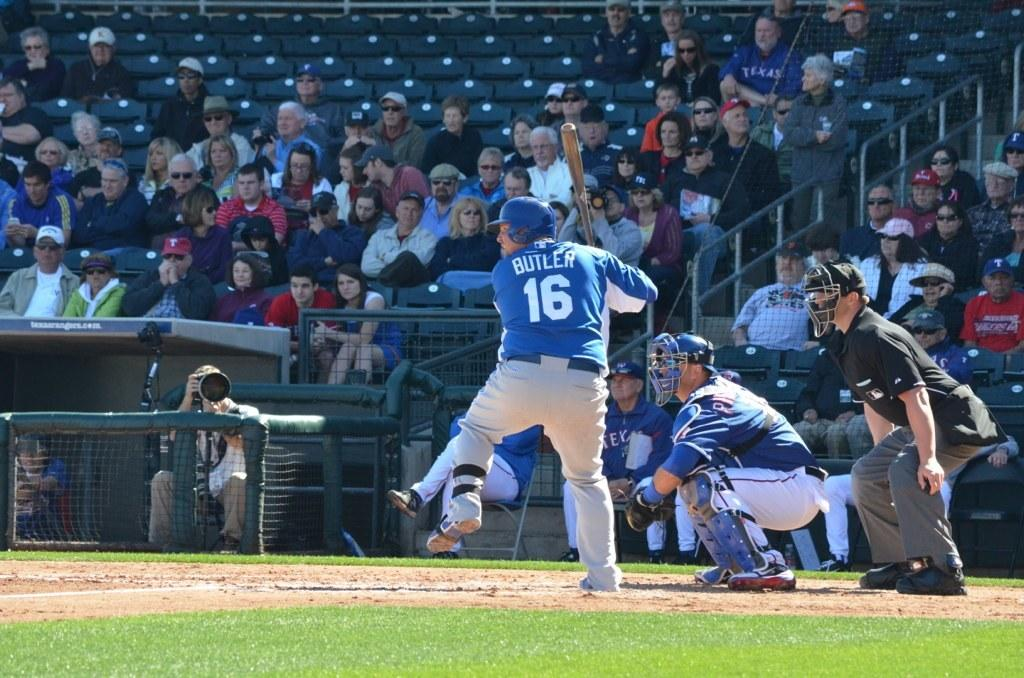Provide a one-sentence caption for the provided image. A baseball player named Butler is about to hit the ball. 